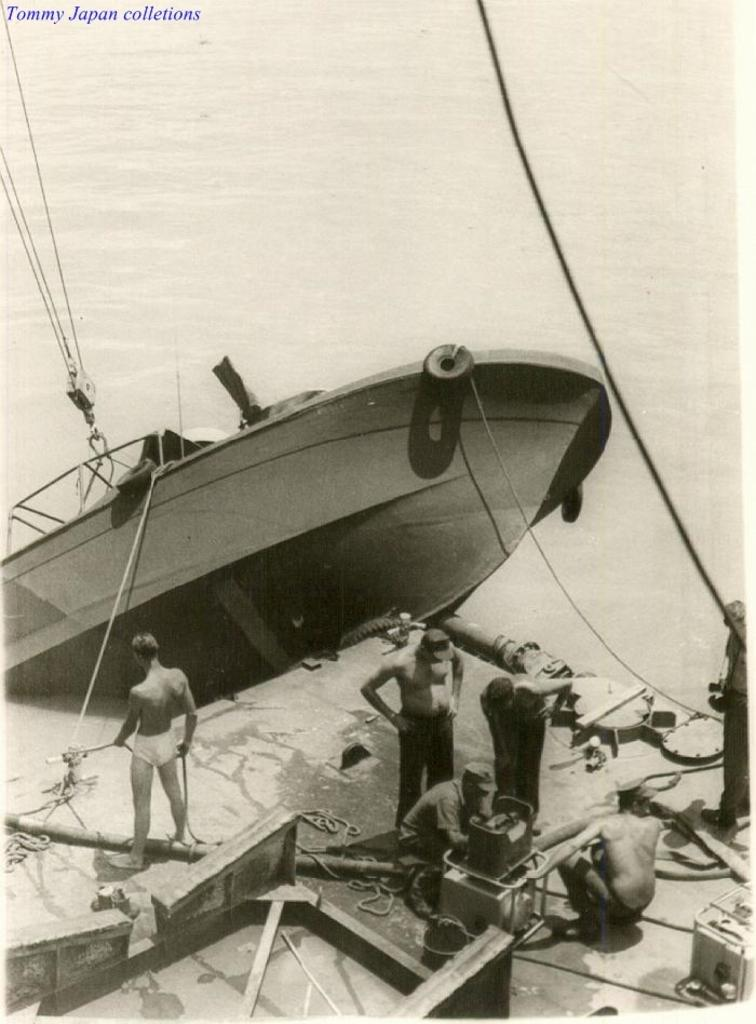What is depicted in the image? There is a picture of a boat in the image. Where are the people located in the image? The people are on a platform in the image. What can be seen connecting the boat and the platform? There are ropes visible in the image. Can you describe any additional elements in the image? There is a watermark in the top left corner of the image. How many donkeys are present on the platform in the image? There are no donkeys present in the image; it features a picture of a boat and people on a platform. What country is the boat from in the image? The image does not provide information about the country of origin for the boat. 